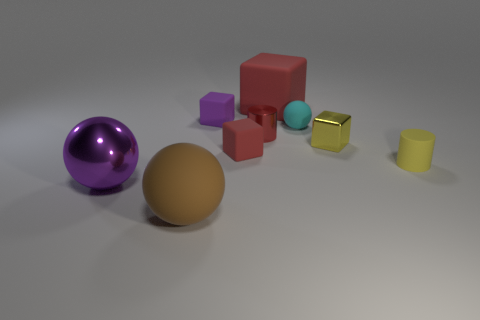There is a cylinder that is the same color as the big matte block; what size is it?
Your response must be concise. Small. How many blocks are the same color as the big metal thing?
Offer a terse response. 1. Is there anything else that is the same color as the tiny metal cylinder?
Your answer should be compact. Yes. What is the large object that is behind the tiny cylinder that is on the right side of the red thing that is behind the small sphere made of?
Give a very brief answer. Rubber. Are there fewer large brown matte balls than small brown rubber things?
Keep it short and to the point. No. Do the tiny cyan sphere and the purple ball have the same material?
Your response must be concise. No. What is the shape of the metal thing that is the same color as the large block?
Your response must be concise. Cylinder. Does the cylinder that is left of the yellow rubber cylinder have the same color as the big block?
Make the answer very short. Yes. There is a large thing that is right of the large brown matte thing; how many purple cubes are in front of it?
Offer a terse response. 1. The ball that is the same size as the metallic cylinder is what color?
Keep it short and to the point. Cyan. 